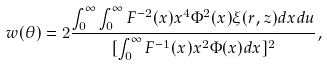<formula> <loc_0><loc_0><loc_500><loc_500>w ( \theta ) = 2 \frac { \int _ { 0 } ^ { \infty } \int _ { 0 } ^ { \infty } F ^ { - 2 } ( x ) x ^ { 4 } \Phi ^ { 2 } ( x ) \xi ( r , z ) d x d u } { [ \int _ { 0 } ^ { \infty } F ^ { - 1 } ( x ) x ^ { 2 } \Phi ( x ) d x ] ^ { 2 } } ,</formula> 